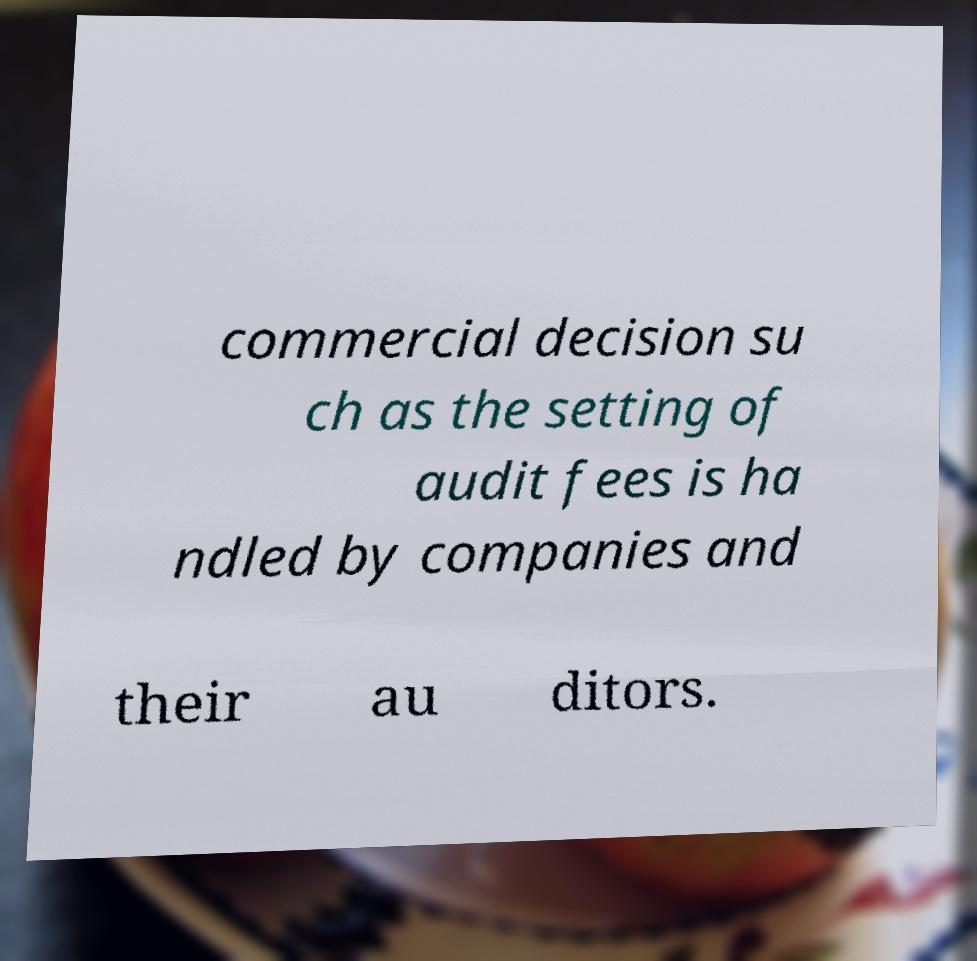For documentation purposes, I need the text within this image transcribed. Could you provide that? commercial decision su ch as the setting of audit fees is ha ndled by companies and their au ditors. 